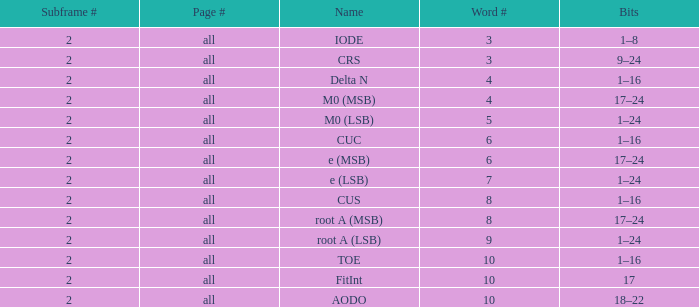What is the total subframe count with Bits of 18–22? 2.0. 